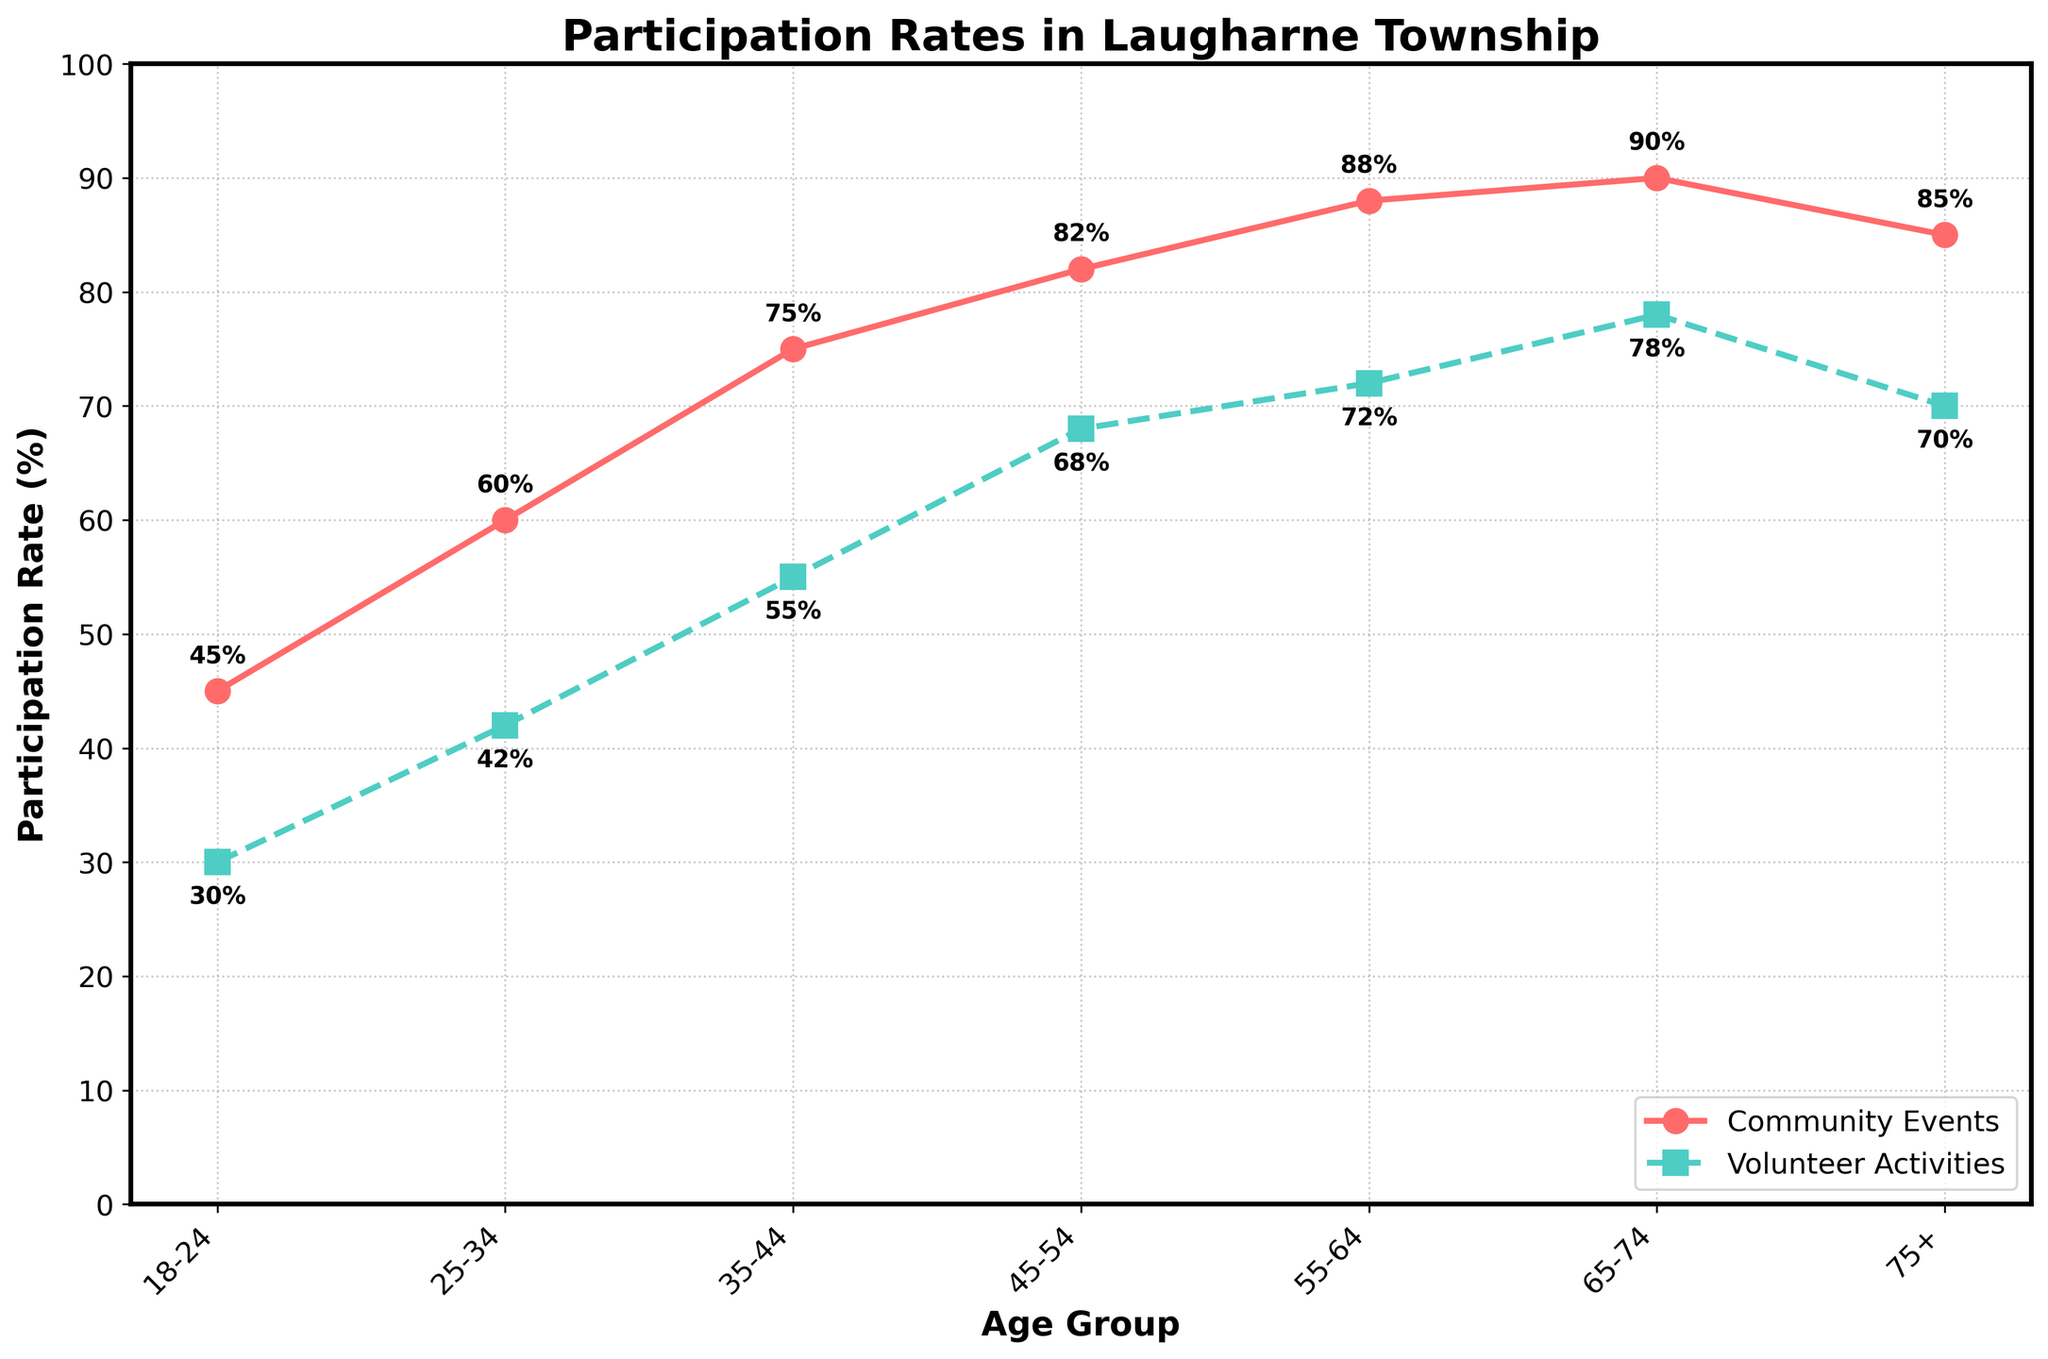What's the participation rate in community events for the age group 45-54? From the figure, look at the line representing Community Events for the age group 45-54. The y-axis value at this point shows the participation rate.
Answer: 82% Compare the participation rates in volunteer activities between the age groups 35-44 and 55-64. From the figure, look at the line representing Volunteer Activities for age groups 35-44 and 55-64. The y-axis values at these points are 55% for 35-44 and 72% for 55-64.
Answer: 55-64 is higher What is the difference in participation rates for community events between the age groups 18-24 and 65-74? From the figure, look at the line representing Community Events for age groups 18-24 and 65-74. The y-axis values are 45% for 18-24 and 90% for 65-74. Subtract the smaller value from the larger one: 90% - 45% = 45%.
Answer: 45% Which age group has the lowest participation rate in volunteer activities, and what is the value? From the figure, look at the line representing Volunteer Activities. The lowest y-axis value corresponds to the age group 18-24, at 30%.
Answer: 18-24, 30% By how much does the participation rate in community events for the age group 75+ differ from the 35-44 age group? From the figure, look at the line representing Community Events for age groups 75+ and 35-44. The y-axis values are 85% for 75+ and 75% for 35-44. Subtract the smaller value from the larger one: 85% - 75% = 10%.
Answer: 10% What trend can be observed in volunteer activities participation as the age groups increase? From the figure, observe the line representing Volunteer Activities. It shows an increasing trend from age 18-24 to 65-74, then a slight decrease at 75+.
Answer: Increasing, then slightly decreasing How do the participation rates in community events compare visually to those in volunteer activities across the age groups? Visually, the line for Community Events is generally higher than that for Volunteer Activities across all age groups, indicating higher participation rates in community events.
Answer: Community Events higher What's the average participation rate in volunteer activities across all age groups? From the figure, add up the y-axis values for Volunteer Activities (30 + 42 + 55 + 68 + 72 + 78 + 70) and divide by the number of age groups (7): (30 + 42 + 55 + 68 + 72 + 78 + 70)/7 = 59.29%.
Answer: 59.29% What is the trend of participation in community events as the age increases from 18 to 74? From the figure, observe the line representing Community Events. It shows a generally increasing trend from age 18-24 to 65-74.
Answer: Increasing In which age group is the gap between community events and volunteer activities participation rates the largest? From the figure, look at the differences between Community Events and Volunteer Activities across all age groups. The largest gap is observed in the age group 45-54, with a difference of 82% - 68% = 14%.
Answer: 45-54, 14% 